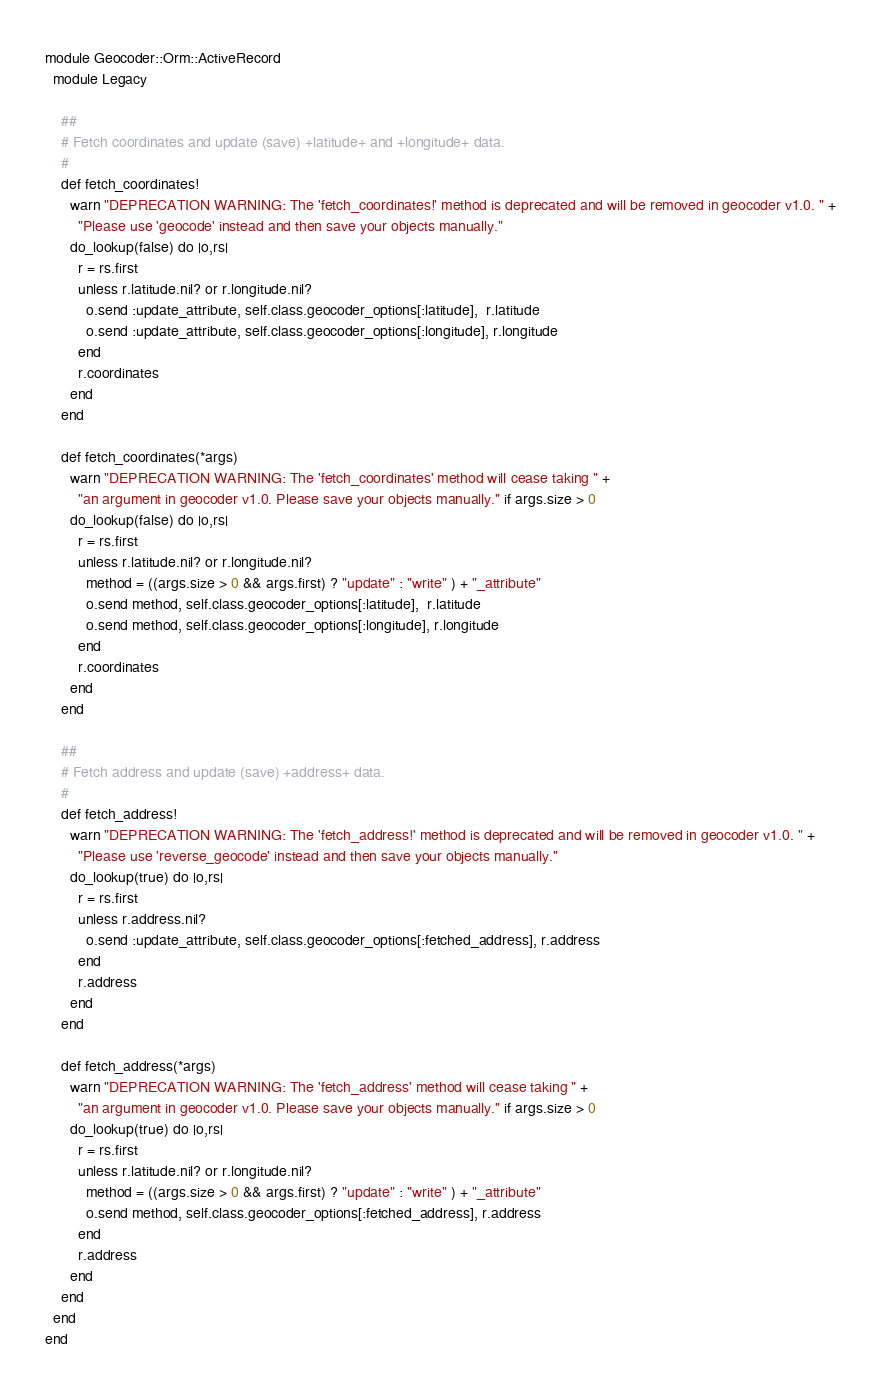Convert code to text. <code><loc_0><loc_0><loc_500><loc_500><_Ruby_>module Geocoder::Orm::ActiveRecord
  module Legacy

    ##
    # Fetch coordinates and update (save) +latitude+ and +longitude+ data.
    #
    def fetch_coordinates!
      warn "DEPRECATION WARNING: The 'fetch_coordinates!' method is deprecated and will be removed in geocoder v1.0. " +
        "Please use 'geocode' instead and then save your objects manually."
      do_lookup(false) do |o,rs|
        r = rs.first
        unless r.latitude.nil? or r.longitude.nil?
          o.send :update_attribute, self.class.geocoder_options[:latitude],  r.latitude
          o.send :update_attribute, self.class.geocoder_options[:longitude], r.longitude
        end
        r.coordinates
      end
    end

    def fetch_coordinates(*args)
      warn "DEPRECATION WARNING: The 'fetch_coordinates' method will cease taking " +
        "an argument in geocoder v1.0. Please save your objects manually." if args.size > 0
      do_lookup(false) do |o,rs|
        r = rs.first
        unless r.latitude.nil? or r.longitude.nil?
          method = ((args.size > 0 && args.first) ? "update" : "write" ) + "_attribute"
          o.send method, self.class.geocoder_options[:latitude],  r.latitude
          o.send method, self.class.geocoder_options[:longitude], r.longitude
        end
        r.coordinates
      end
    end

    ##
    # Fetch address and update (save) +address+ data.
    #
    def fetch_address!
      warn "DEPRECATION WARNING: The 'fetch_address!' method is deprecated and will be removed in geocoder v1.0. " +
        "Please use 'reverse_geocode' instead and then save your objects manually."
      do_lookup(true) do |o,rs|
        r = rs.first
        unless r.address.nil?
          o.send :update_attribute, self.class.geocoder_options[:fetched_address], r.address
        end
        r.address
      end
    end

    def fetch_address(*args)
      warn "DEPRECATION WARNING: The 'fetch_address' method will cease taking " +
        "an argument in geocoder v1.0. Please save your objects manually." if args.size > 0
      do_lookup(true) do |o,rs|
        r = rs.first
        unless r.latitude.nil? or r.longitude.nil?
          method = ((args.size > 0 && args.first) ? "update" : "write" ) + "_attribute"
          o.send method, self.class.geocoder_options[:fetched_address], r.address
        end
        r.address
      end
    end
  end
end
</code> 